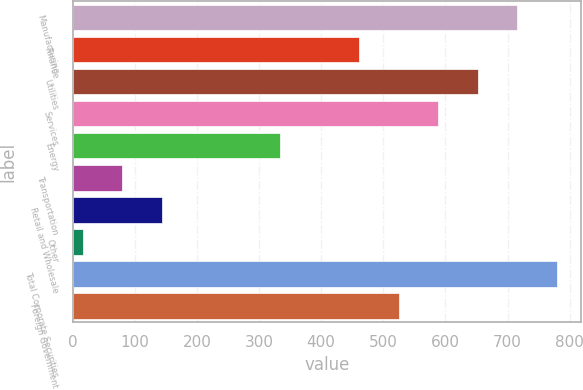Convert chart to OTSL. <chart><loc_0><loc_0><loc_500><loc_500><bar_chart><fcel>Manufacturing<fcel>Finance<fcel>Utilities<fcel>Services<fcel>Energy<fcel>Transportation<fcel>Retail and Wholesale<fcel>Other<fcel>Total Corporate Securities<fcel>Foreign Government<nl><fcel>715.6<fcel>461.2<fcel>652<fcel>588.4<fcel>334<fcel>79.6<fcel>143.2<fcel>16<fcel>779.2<fcel>524.8<nl></chart> 